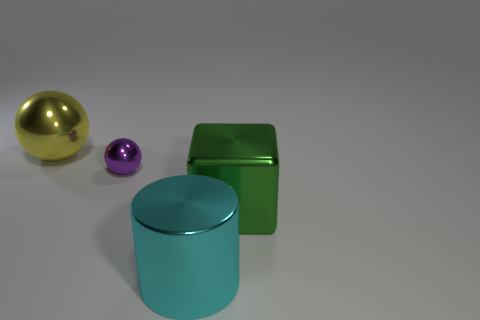Subtract 1 balls. How many balls are left? 1 Subtract all yellow balls. How many balls are left? 1 Add 3 big red shiny objects. How many objects exist? 7 Subtract all brown spheres. Subtract all cyan objects. How many objects are left? 3 Add 2 big balls. How many big balls are left? 3 Add 2 balls. How many balls exist? 4 Subtract 0 red cylinders. How many objects are left? 4 